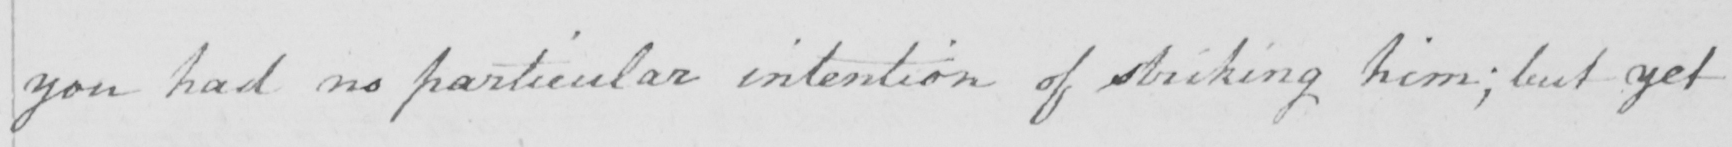What is written in this line of handwriting? you had no particular intention of striking him :  but yet 